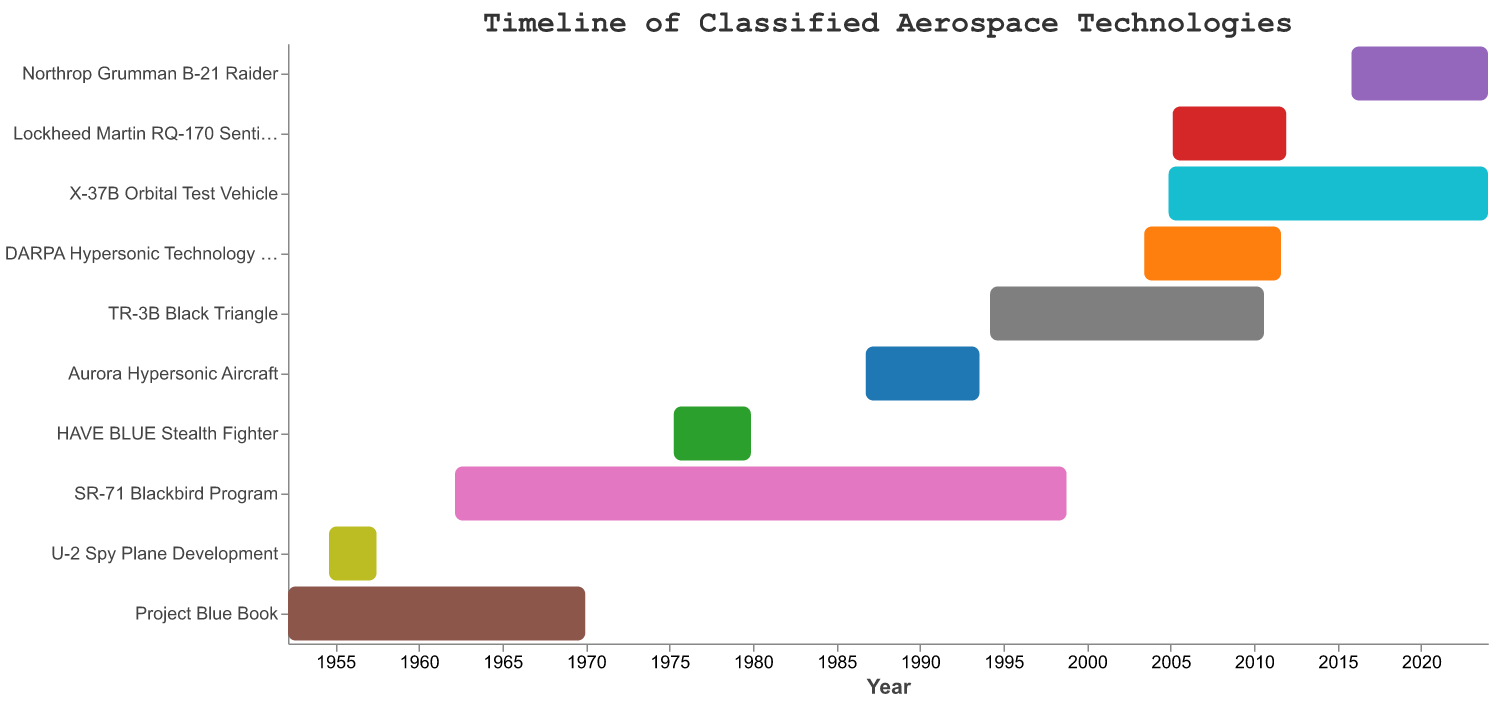What's the title of the figure? The title is located at the top of the figure. By looking at the top, we can see the specific text used as the title.
Answer: Timeline of Classified Aerospace Technologies How many projects started before 1960? To find this, we look at the "Start" dates of all projects and count the ones that began before 1960. The relevant projects are "Project Blue Book" (1952), and "U-2 Spy Plane Development" (1954).
Answer: 2 Which project has the longest duration? We calculate the duration of each project by subtracting the "Start" date from the "End" date in years. The project with the longest duration turns out to be the "SR-71 Blackbird Program" which lasted from 1962 to 1998.
Answer: SR-71 Blackbird Program Which projects are ongoing as of 2023? We need to check which projects have an "End" date set to 2023 or beyond. According to the data, "X-37B Orbital Test Vehicle" and "Northrop Grumman B-21 Raider" are ongoing as of 2023.
Answer: X-37B Orbital Test Vehicle, Northrop Grumman B-21 Raider How many years did the TR-3B Black Triangle project last? We subtract the "Start" date from the "End" date of the TR-3B Black Triangle project to calculate its duration. The project lasted from 1994 to 2010, which is 2010 - 1994 = 16 years.
Answer: 16 years What is the shortest duration project in the chart? To find the shortest duration project, we calculate the duration for each and compare them. The "U-2 Spy Plane Development" project, lasting from 1954 to 1957, is the shortest with a duration of approximately 3 years.
Answer: U-2 Spy Plane Development Which decade saw the start of the most projects? We count the number of projects starting in each decade. The decades are as follows: 1950s (2 projects), 1960s (1 project), 1970s (1 project), 1980s (1 project), 1990s (2 projects), 2000s (3 projects), and 2010s (1 project). The 2000s had the most starts.
Answer: 2000s Which project started immediately after HAVE BLUE Stealth Fighter ended? We look at the "End" date of the HAVE BLUE Stealth Fighter project and find the next project "Start" date. HAVE BLUE ended in November 1979, and the "Aurora Hypersonic Aircraft" started in September 1986.
Answer: Aurora Hypersonic Aircraft 